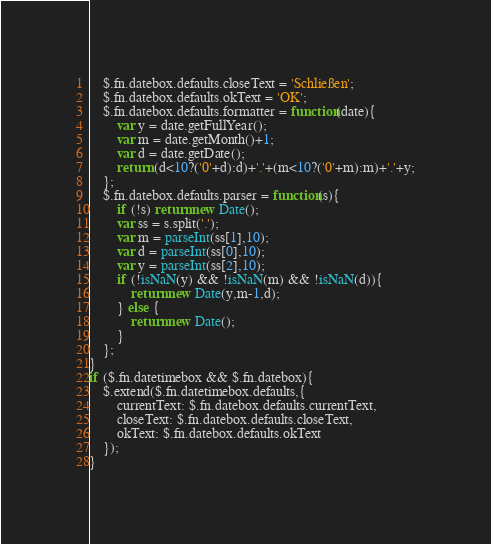Convert code to text. <code><loc_0><loc_0><loc_500><loc_500><_JavaScript_>	$.fn.datebox.defaults.closeText = 'Schließen';
	$.fn.datebox.defaults.okText = 'OK';
	$.fn.datebox.defaults.formatter = function(date){
		var y = date.getFullYear();
		var m = date.getMonth()+1;
		var d = date.getDate();
		return (d<10?('0'+d):d)+'.'+(m<10?('0'+m):m)+'.'+y;
	};
	$.fn.datebox.defaults.parser = function(s){
		if (!s) return new Date();
		var ss = s.split('.');
		var m = parseInt(ss[1],10);
		var d = parseInt(ss[0],10);
		var y = parseInt(ss[2],10);
		if (!isNaN(y) && !isNaN(m) && !isNaN(d)){
			return new Date(y,m-1,d);
		} else {
			return new Date();
		}
	};
}
if ($.fn.datetimebox && $.fn.datebox){
	$.extend($.fn.datetimebox.defaults,{
		currentText: $.fn.datebox.defaults.currentText,
		closeText: $.fn.datebox.defaults.closeText,
		okText: $.fn.datebox.defaults.okText
	});
}
</code> 